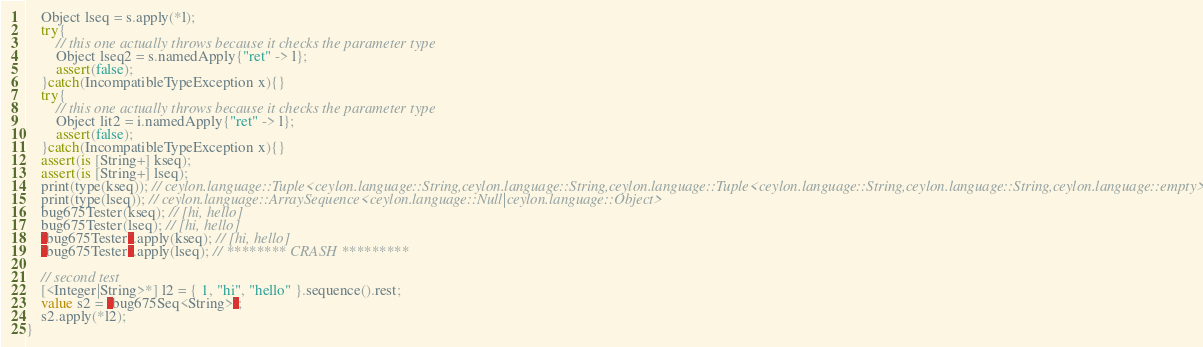<code> <loc_0><loc_0><loc_500><loc_500><_Ceylon_>    Object lseq = s.apply(*l);
    try{
        // this one actually throws because it checks the parameter type
        Object lseq2 = s.namedApply{"ret" -> l};
        assert(false);
    }catch(IncompatibleTypeException x){}
    try{
        // this one actually throws because it checks the parameter type
        Object lit2 = i.namedApply{"ret" -> l};
        assert(false);
    }catch(IncompatibleTypeException x){}
    assert(is [String+] kseq);
    assert(is [String+] lseq);
    print(type(kseq)); // ceylon.language::Tuple<ceylon.language::String,ceylon.language::String,ceylon.language::Tuple<ceylon.language::String,ceylon.language::String,ceylon.language::empty>>
    print(type(lseq)); // ceylon.language::ArraySequence<ceylon.language::Null|ceylon.language::Object>
    bug675Tester(kseq); // [hi, hello]
    bug675Tester(lseq); // [hi, hello]
    `bug675Tester`.apply(kseq); // [hi, hello]
    `bug675Tester`.apply(lseq); // ******** CRASH *********
    
    // second test
    [<Integer|String>*] l2 = { 1, "hi", "hello" }.sequence().rest;
    value s2 = `bug675Seq<String>`;
    s2.apply(*l2);
}
</code> 